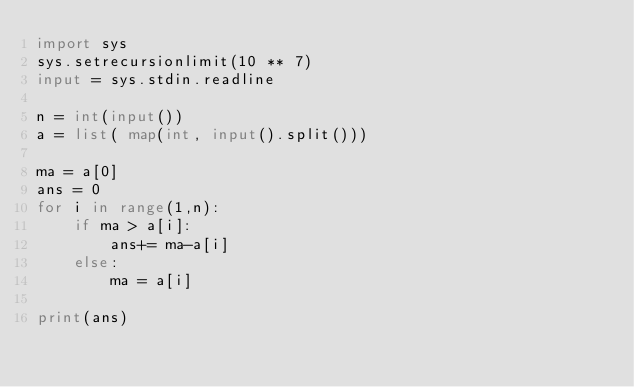Convert code to text. <code><loc_0><loc_0><loc_500><loc_500><_Python_>import sys
sys.setrecursionlimit(10 ** 7)
input = sys.stdin.readline

n = int(input())
a = list( map(int, input().split()))

ma = a[0]
ans = 0
for i in range(1,n):
    if ma > a[i]:
        ans+= ma-a[i]
    else:
        ma = a[i]

print(ans)</code> 